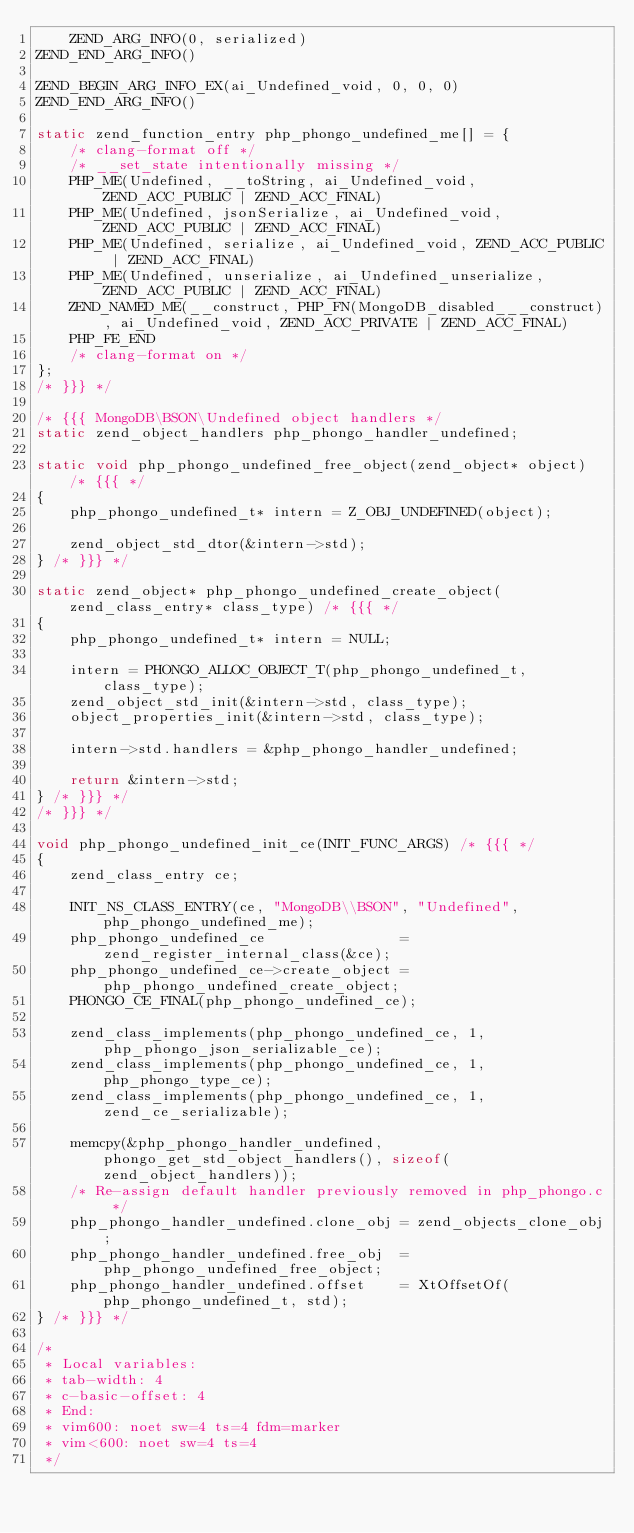Convert code to text. <code><loc_0><loc_0><loc_500><loc_500><_C_>	ZEND_ARG_INFO(0, serialized)
ZEND_END_ARG_INFO()

ZEND_BEGIN_ARG_INFO_EX(ai_Undefined_void, 0, 0, 0)
ZEND_END_ARG_INFO()

static zend_function_entry php_phongo_undefined_me[] = {
	/* clang-format off */
	/* __set_state intentionally missing */
	PHP_ME(Undefined, __toString, ai_Undefined_void, ZEND_ACC_PUBLIC | ZEND_ACC_FINAL)
	PHP_ME(Undefined, jsonSerialize, ai_Undefined_void, ZEND_ACC_PUBLIC | ZEND_ACC_FINAL)
	PHP_ME(Undefined, serialize, ai_Undefined_void, ZEND_ACC_PUBLIC | ZEND_ACC_FINAL)
	PHP_ME(Undefined, unserialize, ai_Undefined_unserialize, ZEND_ACC_PUBLIC | ZEND_ACC_FINAL)
	ZEND_NAMED_ME(__construct, PHP_FN(MongoDB_disabled___construct), ai_Undefined_void, ZEND_ACC_PRIVATE | ZEND_ACC_FINAL)
	PHP_FE_END
	/* clang-format on */
};
/* }}} */

/* {{{ MongoDB\BSON\Undefined object handlers */
static zend_object_handlers php_phongo_handler_undefined;

static void php_phongo_undefined_free_object(zend_object* object) /* {{{ */
{
	php_phongo_undefined_t* intern = Z_OBJ_UNDEFINED(object);

	zend_object_std_dtor(&intern->std);
} /* }}} */

static zend_object* php_phongo_undefined_create_object(zend_class_entry* class_type) /* {{{ */
{
	php_phongo_undefined_t* intern = NULL;

	intern = PHONGO_ALLOC_OBJECT_T(php_phongo_undefined_t, class_type);
	zend_object_std_init(&intern->std, class_type);
	object_properties_init(&intern->std, class_type);

	intern->std.handlers = &php_phongo_handler_undefined;

	return &intern->std;
} /* }}} */
/* }}} */

void php_phongo_undefined_init_ce(INIT_FUNC_ARGS) /* {{{ */
{
	zend_class_entry ce;

	INIT_NS_CLASS_ENTRY(ce, "MongoDB\\BSON", "Undefined", php_phongo_undefined_me);
	php_phongo_undefined_ce                = zend_register_internal_class(&ce);
	php_phongo_undefined_ce->create_object = php_phongo_undefined_create_object;
	PHONGO_CE_FINAL(php_phongo_undefined_ce);

	zend_class_implements(php_phongo_undefined_ce, 1, php_phongo_json_serializable_ce);
	zend_class_implements(php_phongo_undefined_ce, 1, php_phongo_type_ce);
	zend_class_implements(php_phongo_undefined_ce, 1, zend_ce_serializable);

	memcpy(&php_phongo_handler_undefined, phongo_get_std_object_handlers(), sizeof(zend_object_handlers));
	/* Re-assign default handler previously removed in php_phongo.c */
	php_phongo_handler_undefined.clone_obj = zend_objects_clone_obj;
	php_phongo_handler_undefined.free_obj  = php_phongo_undefined_free_object;
	php_phongo_handler_undefined.offset    = XtOffsetOf(php_phongo_undefined_t, std);
} /* }}} */

/*
 * Local variables:
 * tab-width: 4
 * c-basic-offset: 4
 * End:
 * vim600: noet sw=4 ts=4 fdm=marker
 * vim<600: noet sw=4 ts=4
 */
</code> 